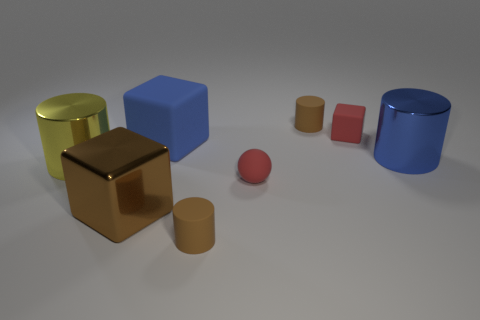Which objects in the image seem related and why? The small and large cylinders appear related due to their similar material and shape but different sizes, suggesting they could be part of a set. Similarly, the two cubes are related by shape, differing only in size and texture. Can you guess what the purpose of these objects might be in real life? These objects might serve as models or prototypes for design purposes, teaching aids to demonstrate geometry and materials, or simply as decorative elements due to their simple yet aesthetically pleasing forms and varying textures. 